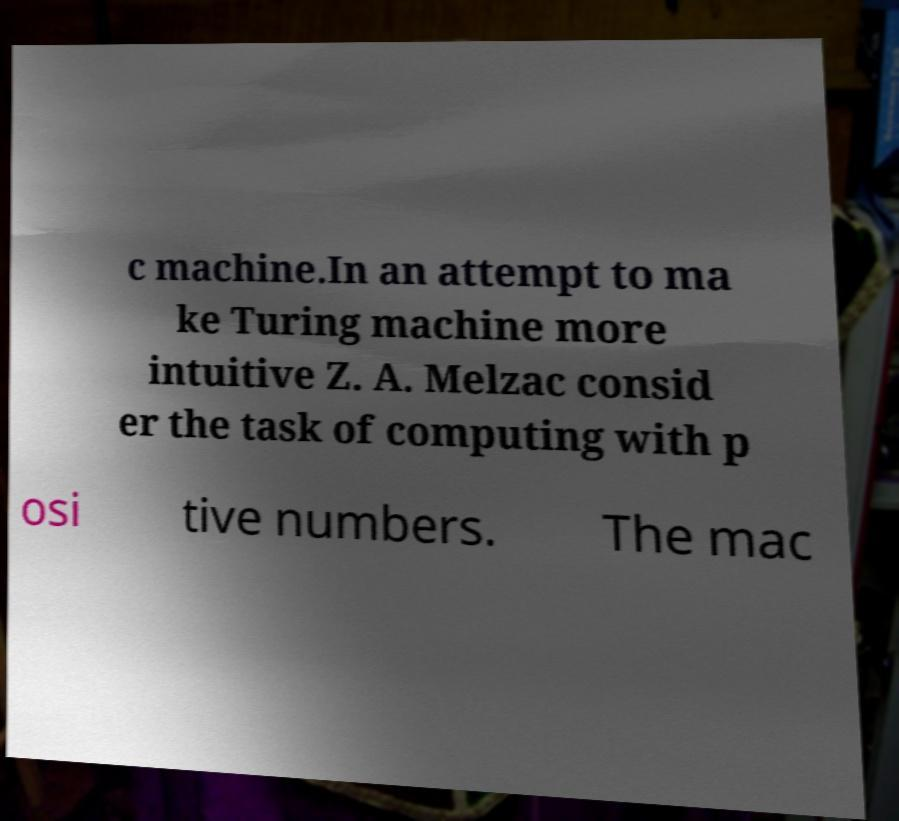What messages or text are displayed in this image? I need them in a readable, typed format. c machine.In an attempt to ma ke Turing machine more intuitive Z. A. Melzac consid er the task of computing with p osi tive numbers. The mac 